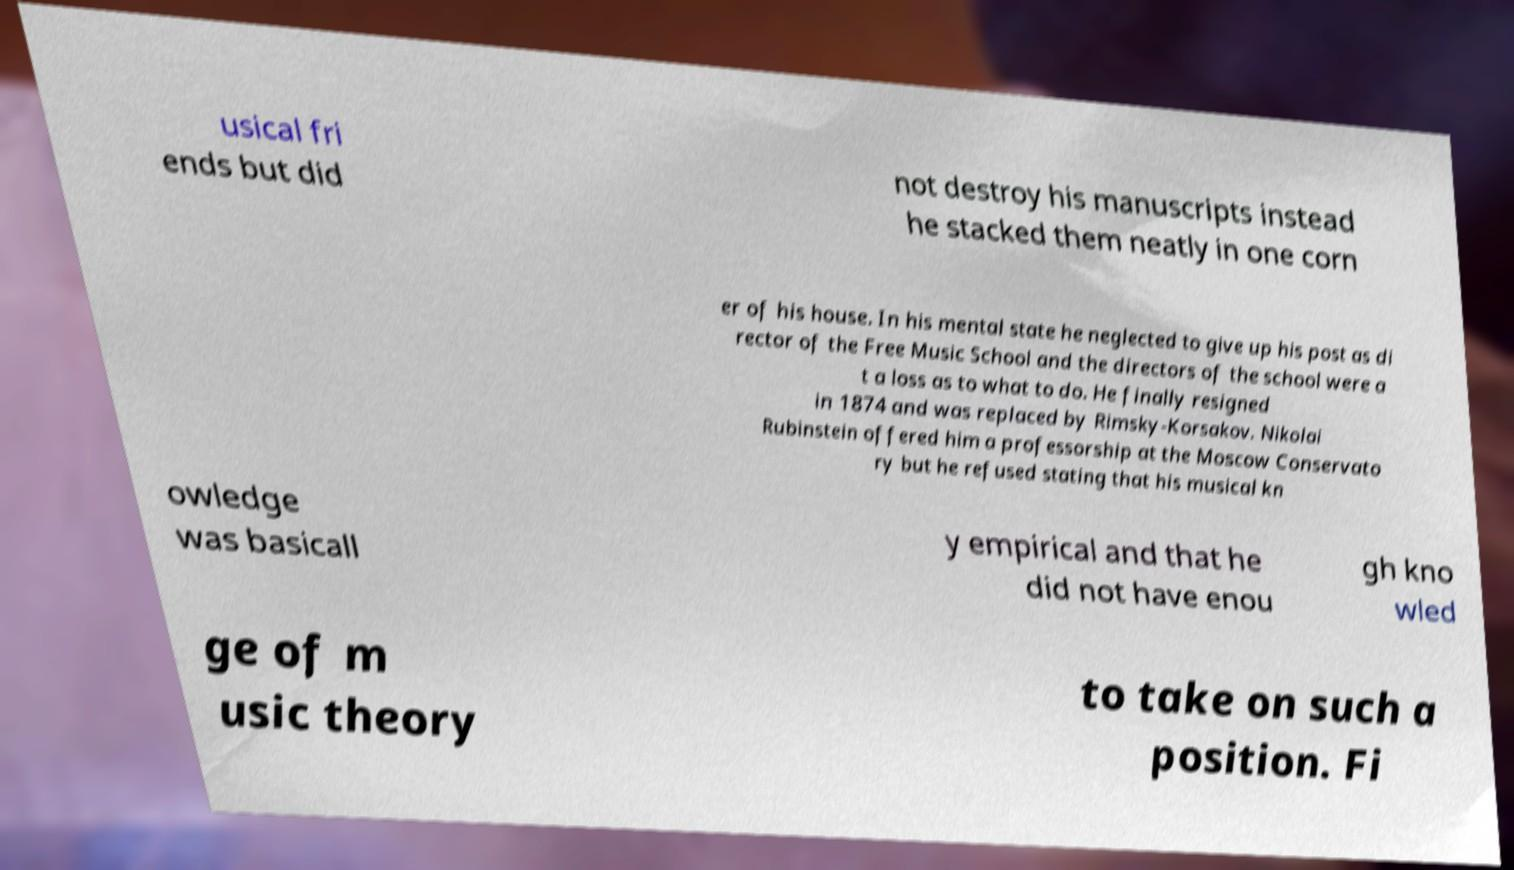Can you read and provide the text displayed in the image?This photo seems to have some interesting text. Can you extract and type it out for me? usical fri ends but did not destroy his manuscripts instead he stacked them neatly in one corn er of his house. In his mental state he neglected to give up his post as di rector of the Free Music School and the directors of the school were a t a loss as to what to do. He finally resigned in 1874 and was replaced by Rimsky-Korsakov. Nikolai Rubinstein offered him a professorship at the Moscow Conservato ry but he refused stating that his musical kn owledge was basicall y empirical and that he did not have enou gh kno wled ge of m usic theory to take on such a position. Fi 